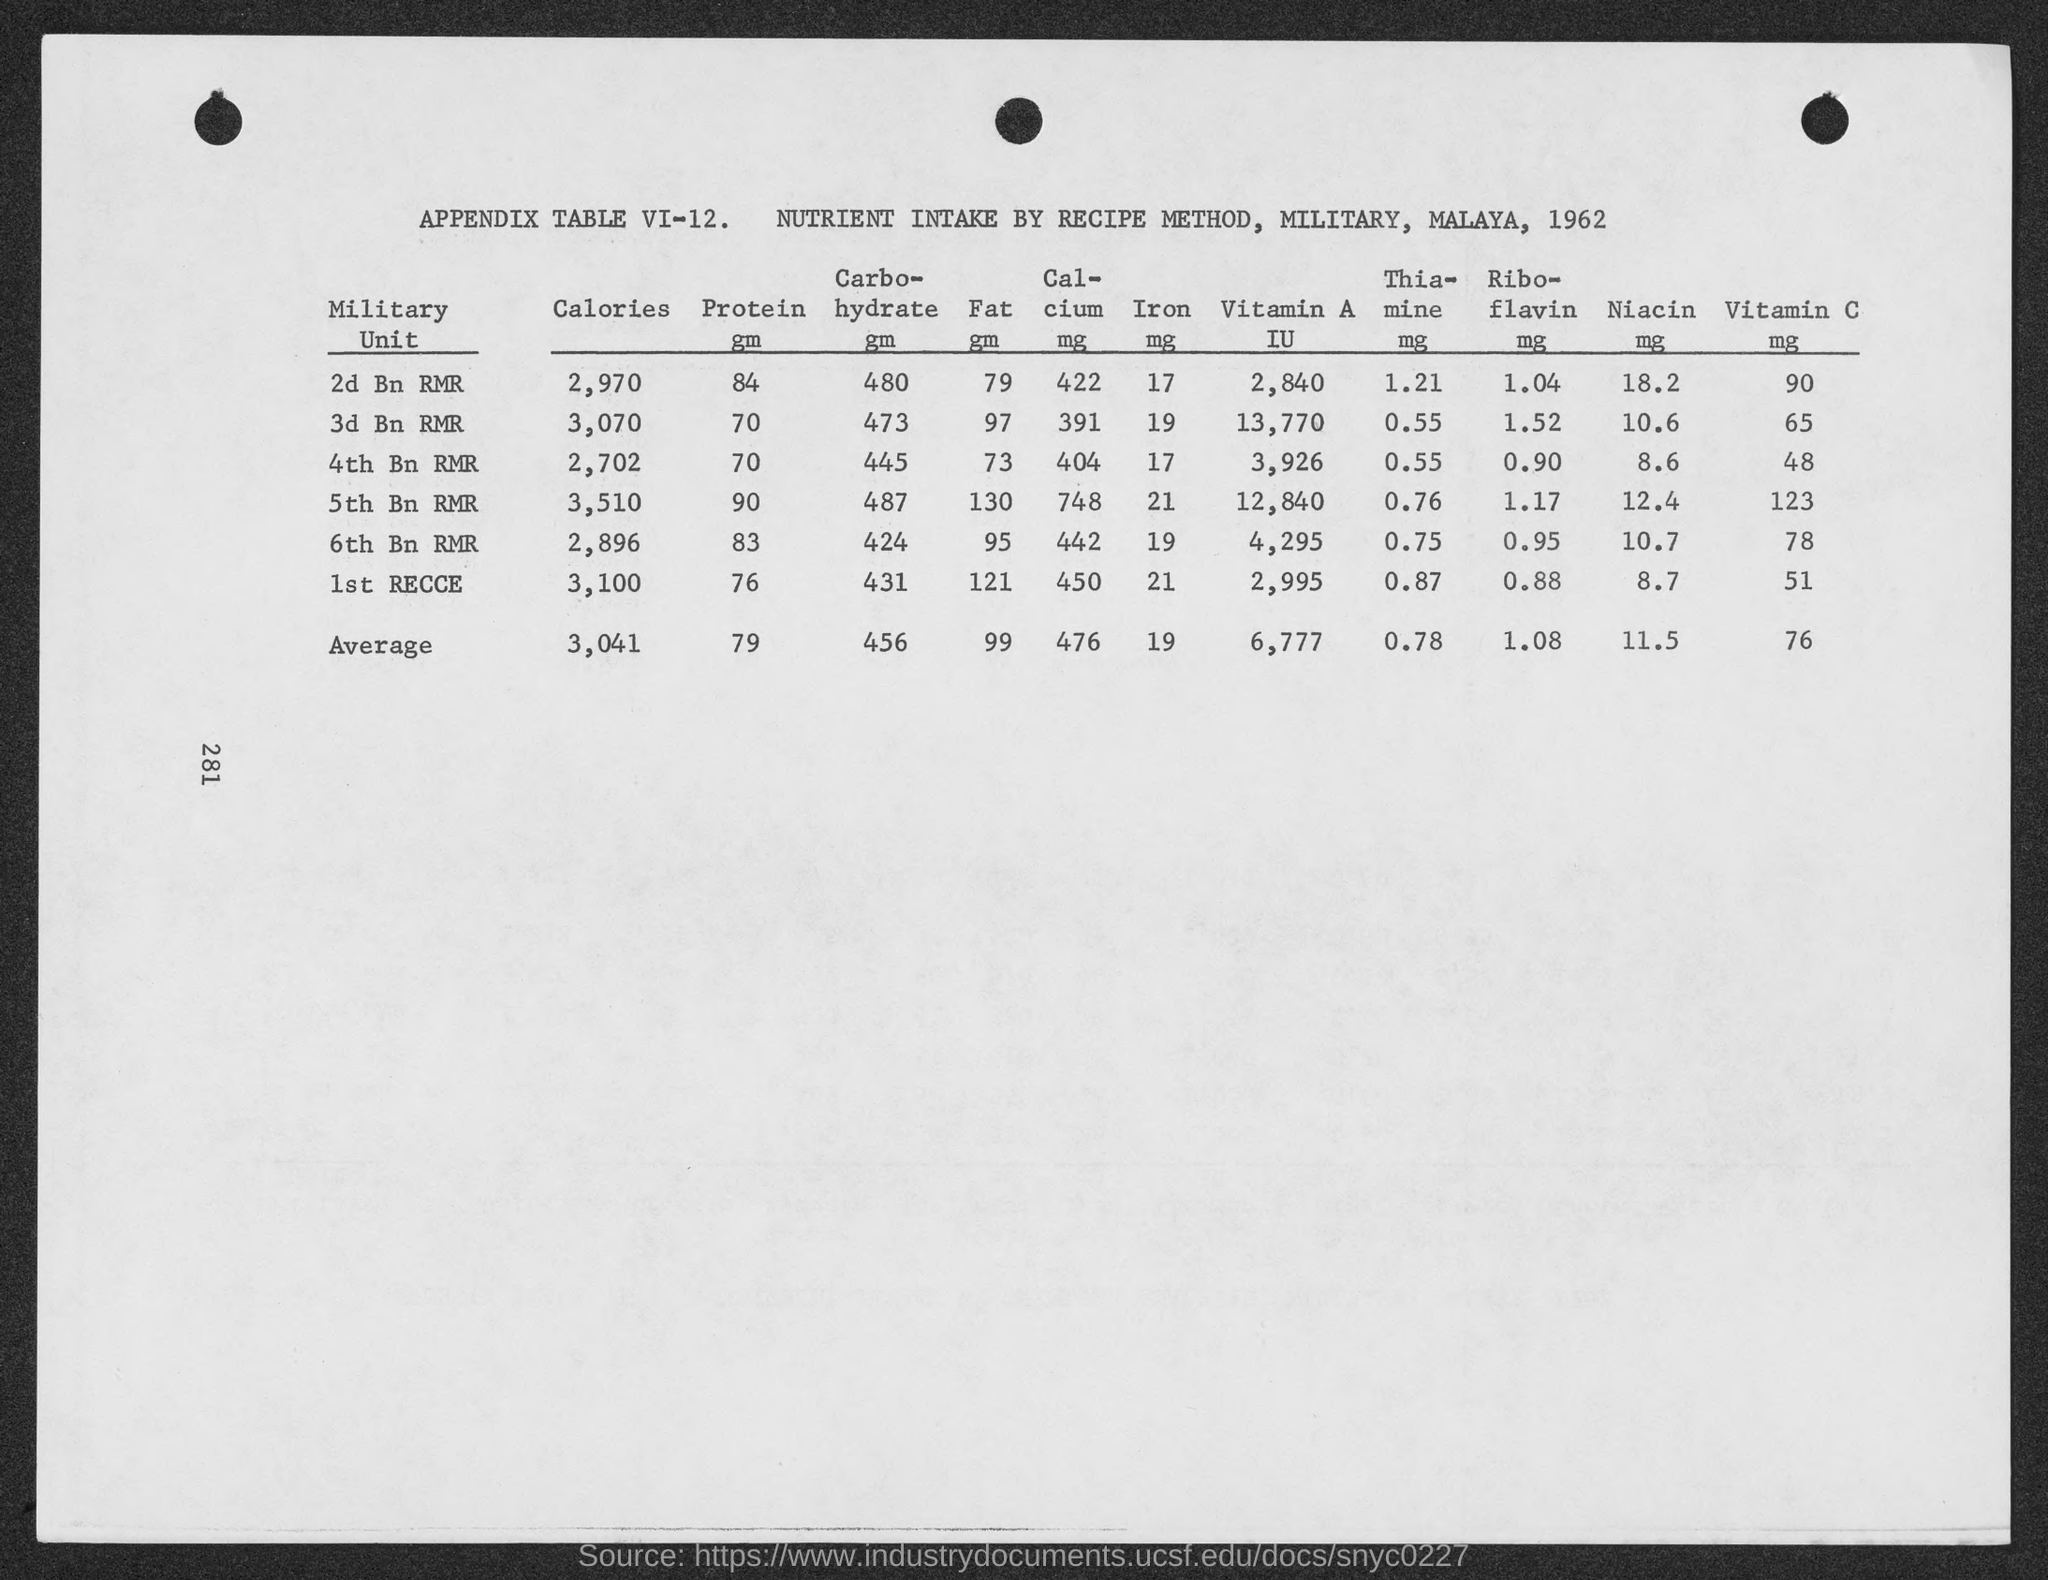What is the average value of calories mentioned in the given table ?
Give a very brief answer. 3,041. What is the average value of protein mentioned in the given table ?
Offer a terse response. 79. What is the average value of carbohydrate mentioned in the given table ?
Give a very brief answer. 456. What is the average value of fat mentioned in the given table ?
Give a very brief answer. 99. What is the average value of calcium mentioned in the given table ?
Provide a succinct answer. 476. What is the average value of iron mentioned in the given table ?
Make the answer very short. 19. What is the average value of vitamin a  mentioned in the given table ?
Your response must be concise. 6,777. What is the average value of thiamine mentioned in the given table ?
Make the answer very short. 0.78. What is the average value of riboflavin mentioned in the given table ?
Offer a very short reply. 1.08. What is the average value of niacin mentioned in the given table ?
Offer a very short reply. 11.5. 